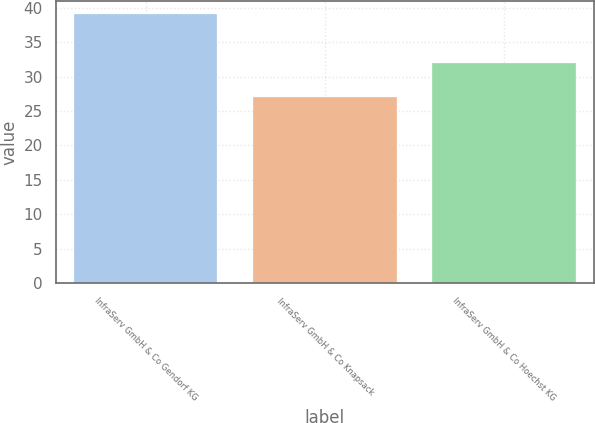Convert chart. <chart><loc_0><loc_0><loc_500><loc_500><bar_chart><fcel>InfraServ GmbH & Co Gendorf KG<fcel>InfraServ GmbH & Co Knapsack<fcel>InfraServ GmbH & Co Hoechst KG<nl><fcel>39<fcel>27<fcel>32<nl></chart> 